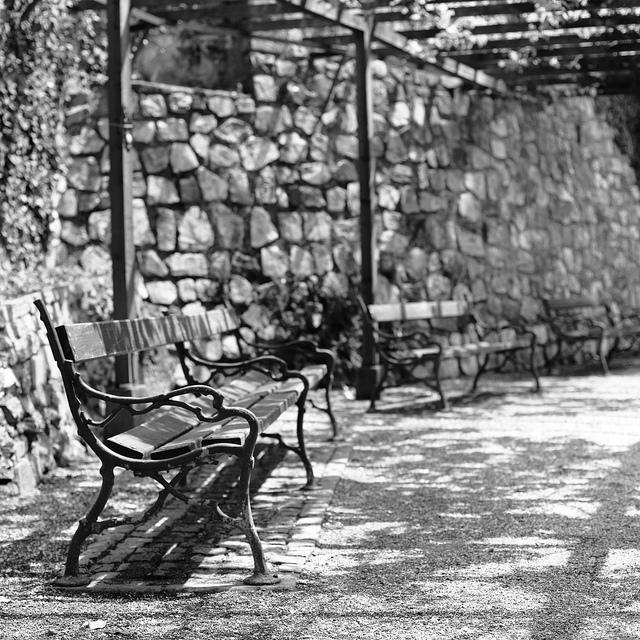How many benches can be seen?
Give a very brief answer. 3. How many people are walking?
Give a very brief answer. 0. 